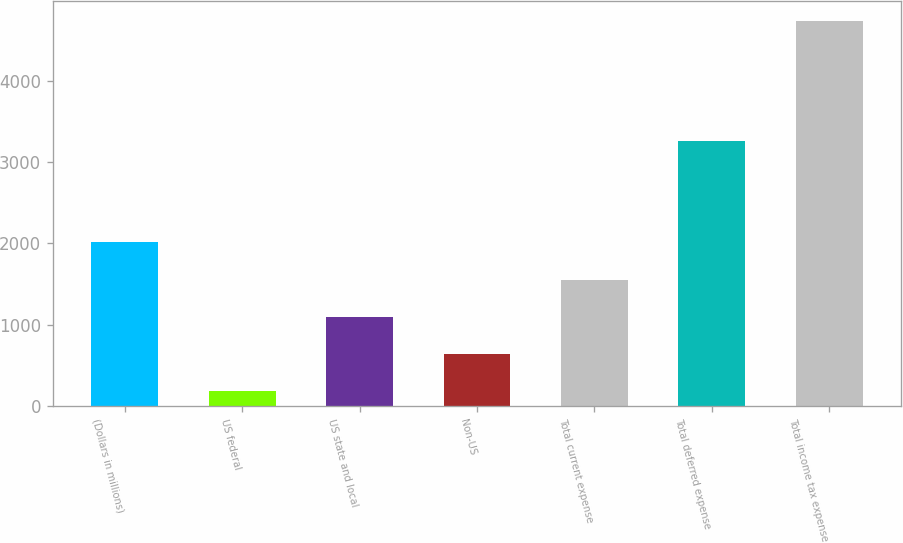Convert chart. <chart><loc_0><loc_0><loc_500><loc_500><bar_chart><fcel>(Dollars in millions)<fcel>US federal<fcel>US state and local<fcel>Non-US<fcel>Total current expense<fcel>Total deferred expense<fcel>Total income tax expense<nl><fcel>2013<fcel>180<fcel>1092.2<fcel>636.1<fcel>1548.3<fcel>3262<fcel>4741<nl></chart> 